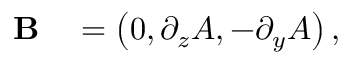<formula> <loc_0><loc_0><loc_500><loc_500>\begin{array} { r l } { B } & = \left ( 0 , \partial _ { z } A , - \partial _ { y } A \right ) , } \end{array}</formula> 